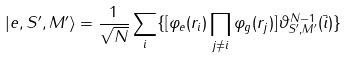Convert formula to latex. <formula><loc_0><loc_0><loc_500><loc_500>| e , S ^ { \prime } , M ^ { \prime } \rangle = \frac { 1 } { \sqrt { N } } \sum _ { i } \{ [ \varphi _ { e } ( r _ { i } ) \prod _ { j \ne i } \varphi _ { g } ( r _ { j } ) ] \vartheta ^ { N - 1 } _ { S ^ { \prime } , M ^ { \prime } } ( \bar { i } ) \}</formula> 